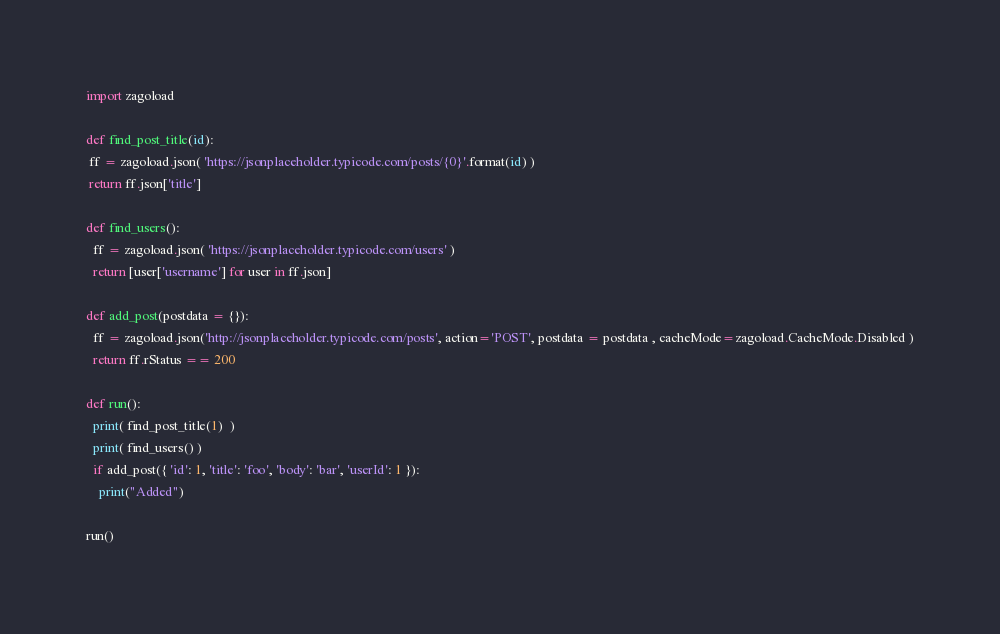<code> <loc_0><loc_0><loc_500><loc_500><_Python_>import zagoload

def find_post_title(id):
 ff = zagoload.json( 'https://jsonplaceholder.typicode.com/posts/{0}'.format(id) )
 return ff.json['title']

def find_users():
  ff = zagoload.json( 'https://jsonplaceholder.typicode.com/users' )
  return [user['username'] for user in ff.json]

def add_post(postdata = {}):
  ff = zagoload.json('http://jsonplaceholder.typicode.com/posts', action='POST', postdata = postdata , cacheMode=zagoload.CacheMode.Disabled )
  return ff.rStatus == 200

def run():
  print( find_post_title(1)  )
  print( find_users() )
  if add_post({ 'id': 1, 'title': 'foo', 'body': 'bar', 'userId': 1 }):
    print("Added")

run()
</code> 